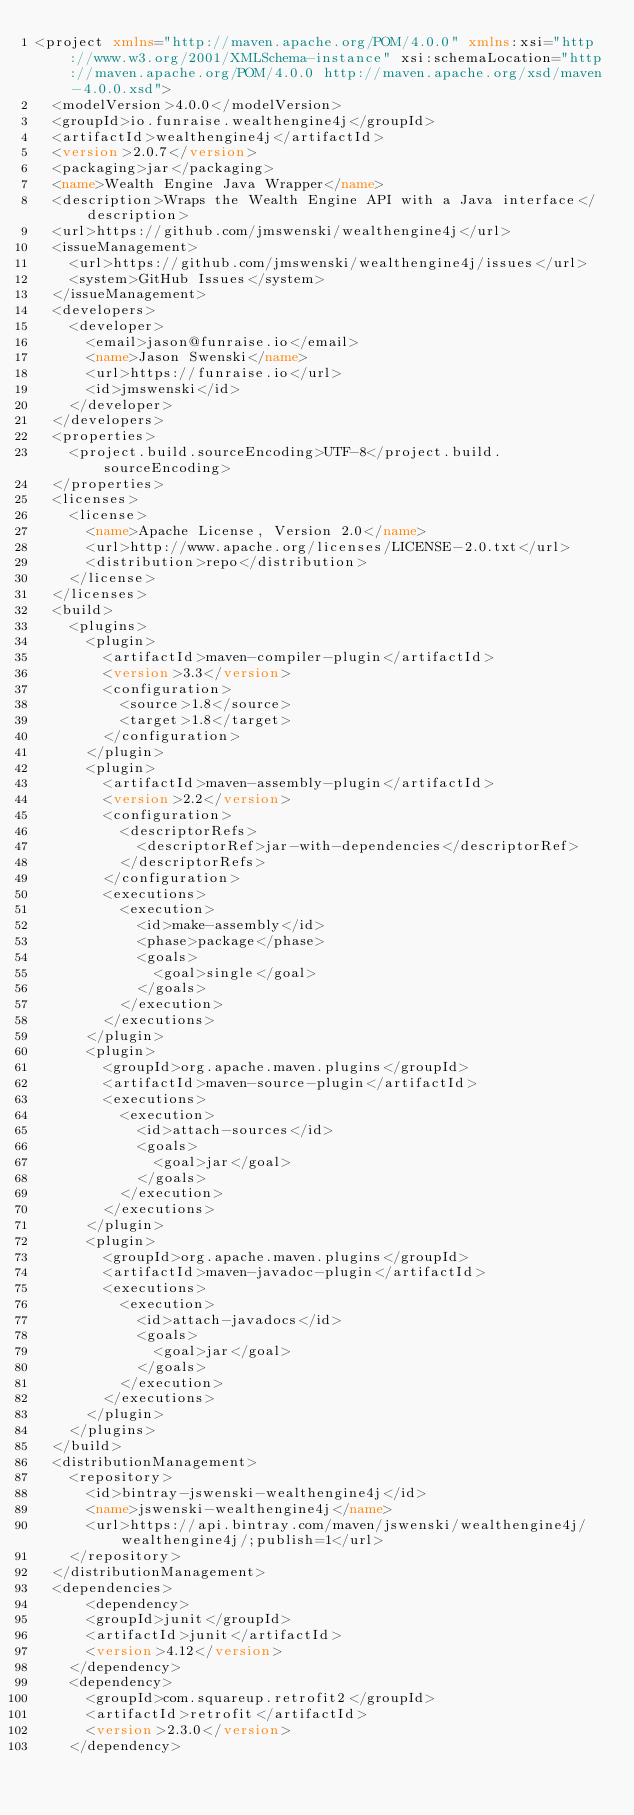Convert code to text. <code><loc_0><loc_0><loc_500><loc_500><_XML_><project xmlns="http://maven.apache.org/POM/4.0.0" xmlns:xsi="http://www.w3.org/2001/XMLSchema-instance" xsi:schemaLocation="http://maven.apache.org/POM/4.0.0 http://maven.apache.org/xsd/maven-4.0.0.xsd">
  <modelVersion>4.0.0</modelVersion>
  <groupId>io.funraise.wealthengine4j</groupId>
  <artifactId>wealthengine4j</artifactId>
  <version>2.0.7</version>
  <packaging>jar</packaging>
  <name>Wealth Engine Java Wrapper</name>
  <description>Wraps the Wealth Engine API with a Java interface</description>
  <url>https://github.com/jmswenski/wealthengine4j</url>
  <issueManagement>
    <url>https://github.com/jmswenski/wealthengine4j/issues</url>
    <system>GitHub Issues</system>
  </issueManagement>
  <developers>
    <developer>
      <email>jason@funraise.io</email>
      <name>Jason Swenski</name>
      <url>https://funraise.io</url>
      <id>jmswenski</id>
    </developer>
  </developers>
  <properties>
    <project.build.sourceEncoding>UTF-8</project.build.sourceEncoding>
  </properties>
  <licenses>
    <license>
      <name>Apache License, Version 2.0</name>
      <url>http://www.apache.org/licenses/LICENSE-2.0.txt</url>
      <distribution>repo</distribution>
    </license>
  </licenses>
  <build>
    <plugins>
      <plugin>
        <artifactId>maven-compiler-plugin</artifactId>
        <version>3.3</version>
        <configuration>
          <source>1.8</source>
          <target>1.8</target>
        </configuration>
      </plugin>
      <plugin>
        <artifactId>maven-assembly-plugin</artifactId>
        <version>2.2</version>
        <configuration>
          <descriptorRefs>
            <descriptorRef>jar-with-dependencies</descriptorRef>
          </descriptorRefs>
        </configuration>
        <executions>
          <execution>
            <id>make-assembly</id>
            <phase>package</phase>
            <goals>
              <goal>single</goal>
            </goals>
          </execution>
        </executions>
      </plugin>
      <plugin>
        <groupId>org.apache.maven.plugins</groupId>
        <artifactId>maven-source-plugin</artifactId>
        <executions>
          <execution>
            <id>attach-sources</id>
            <goals>
              <goal>jar</goal>
            </goals>
          </execution>
        </executions>
      </plugin>
      <plugin>
        <groupId>org.apache.maven.plugins</groupId>
        <artifactId>maven-javadoc-plugin</artifactId>
        <executions>
          <execution>
            <id>attach-javadocs</id>
            <goals>
              <goal>jar</goal>
            </goals>
          </execution>
        </executions>
      </plugin>
    </plugins>
  </build>
  <distributionManagement>
    <repository>
      <id>bintray-jswenski-wealthengine4j</id>
      <name>jswenski-wealthengine4j</name>
      <url>https://api.bintray.com/maven/jswenski/wealthengine4j/wealthengine4j/;publish=1</url>
    </repository>
  </distributionManagement>
  <dependencies>
      <dependency>
      <groupId>junit</groupId>
      <artifactId>junit</artifactId>
      <version>4.12</version>
    </dependency>
    <dependency>
      <groupId>com.squareup.retrofit2</groupId>
      <artifactId>retrofit</artifactId>
      <version>2.3.0</version>
    </dependency></code> 